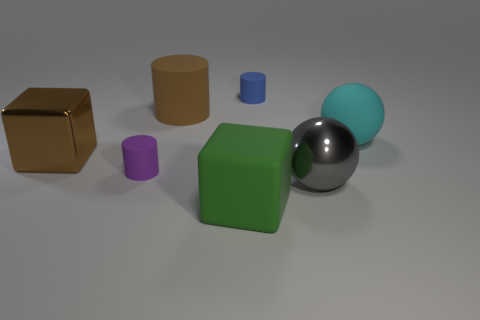Is the number of green rubber blocks in front of the brown cube greater than the number of blue shiny spheres?
Your response must be concise. Yes. How many cylinders are behind the metal thing that is left of the large rubber object behind the cyan object?
Provide a short and direct response. 2. There is a object that is in front of the small purple cylinder and to the left of the big gray metallic object; what material is it?
Make the answer very short. Rubber. What color is the matte block?
Your answer should be very brief. Green. Are there more blocks that are on the left side of the cyan rubber object than rubber cubes behind the tiny blue object?
Keep it short and to the point. Yes. What color is the thing in front of the large gray sphere?
Make the answer very short. Green. There is a rubber thing that is to the right of the big gray shiny sphere; does it have the same size as the matte object in front of the big gray thing?
Your response must be concise. Yes. What number of things are big cyan shiny spheres or cyan rubber spheres?
Offer a terse response. 1. What is the material of the big brown object that is to the left of the cylinder that is in front of the brown metallic cube?
Your response must be concise. Metal. What number of small things have the same shape as the large green matte thing?
Ensure brevity in your answer.  0. 